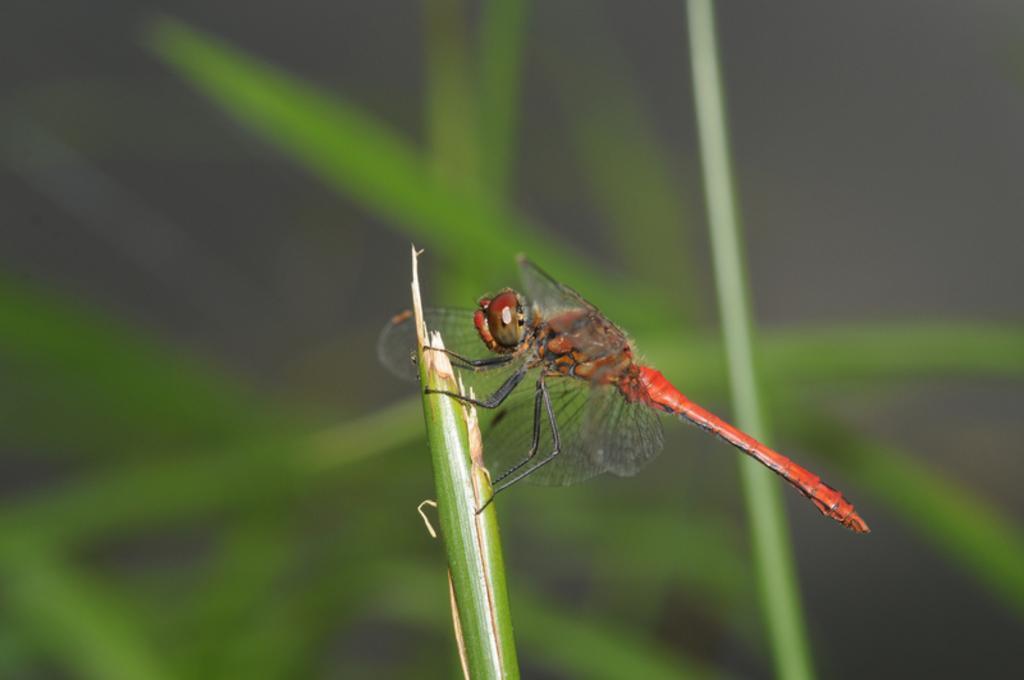Describe this image in one or two sentences. In this image I can see a dragonfly on a leaf. In the background, I can see some more leaves. The background is blurred. 